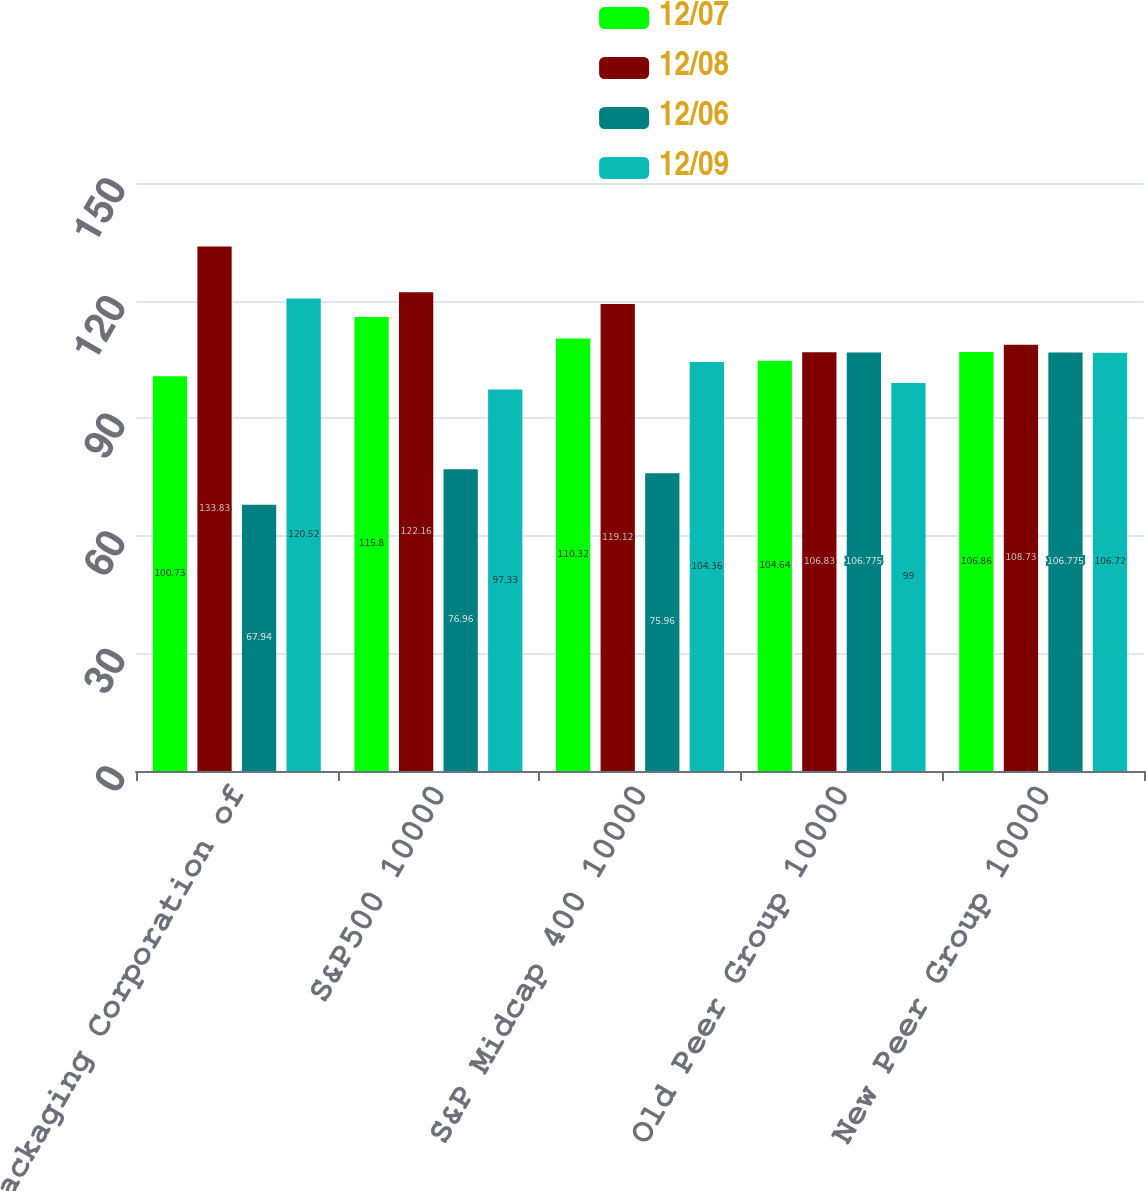Convert chart to OTSL. <chart><loc_0><loc_0><loc_500><loc_500><stacked_bar_chart><ecel><fcel>Packaging Corporation of<fcel>S&P500 10000<fcel>S&P Midcap 400 10000<fcel>Old Peer Group 10000<fcel>New Peer Group 10000<nl><fcel>12/07<fcel>100.73<fcel>115.8<fcel>110.32<fcel>104.64<fcel>106.86<nl><fcel>12/08<fcel>133.83<fcel>122.16<fcel>119.12<fcel>106.83<fcel>108.73<nl><fcel>12/06<fcel>67.94<fcel>76.96<fcel>75.96<fcel>106.775<fcel>106.775<nl><fcel>12/09<fcel>120.52<fcel>97.33<fcel>104.36<fcel>99<fcel>106.72<nl></chart> 